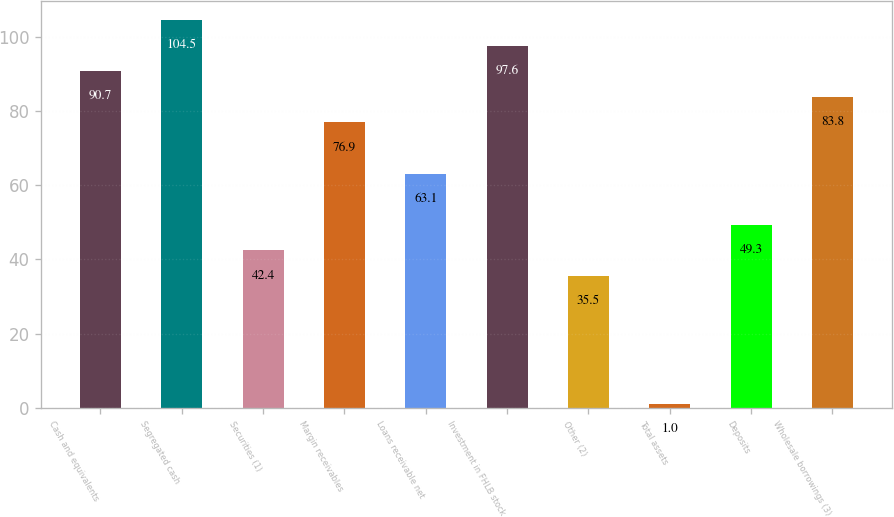Convert chart. <chart><loc_0><loc_0><loc_500><loc_500><bar_chart><fcel>Cash and equivalents<fcel>Segregated cash<fcel>Securities (1)<fcel>Margin receivables<fcel>Loans receivable net<fcel>Investment in FHLB stock<fcel>Other (2)<fcel>Total assets<fcel>Deposits<fcel>Wholesale borrowings (3)<nl><fcel>90.7<fcel>104.5<fcel>42.4<fcel>76.9<fcel>63.1<fcel>97.6<fcel>35.5<fcel>1<fcel>49.3<fcel>83.8<nl></chart> 